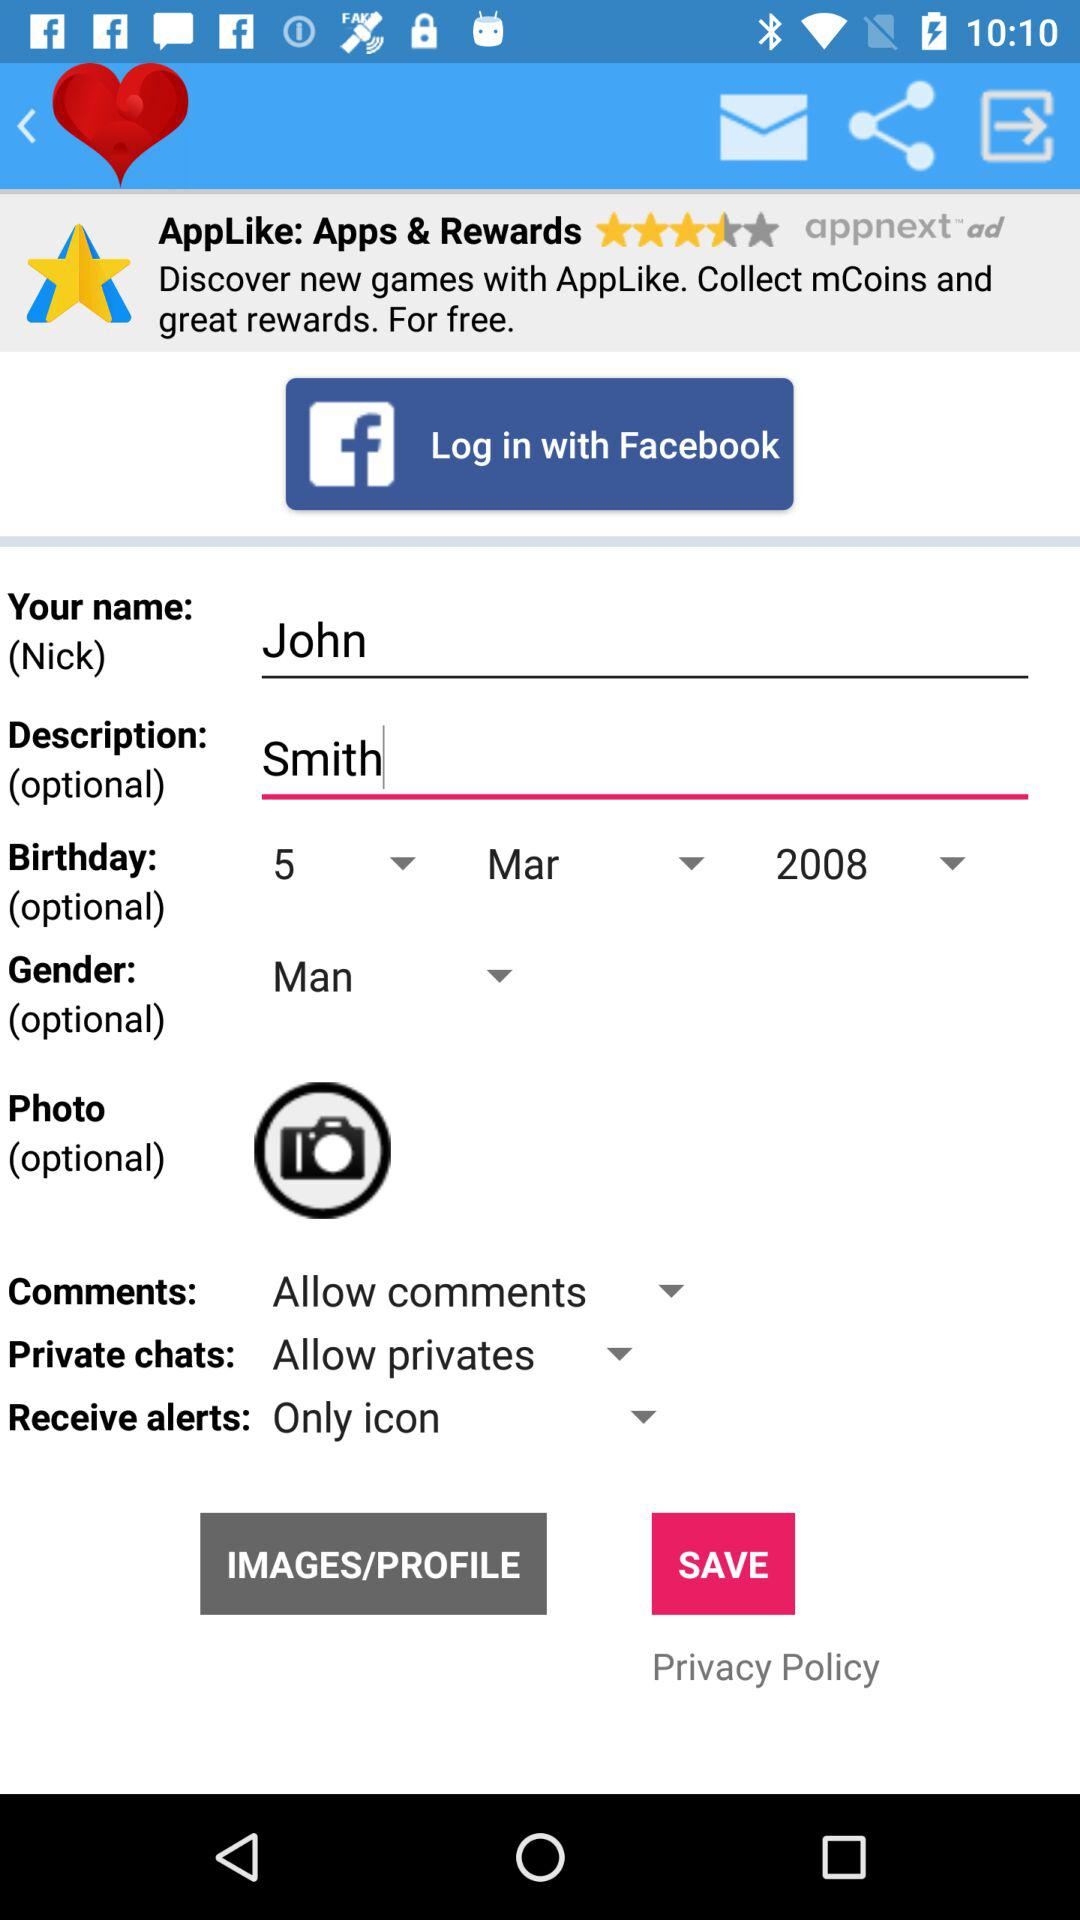What is the setting for private chats? The setting for private chats is "Allow privates". 